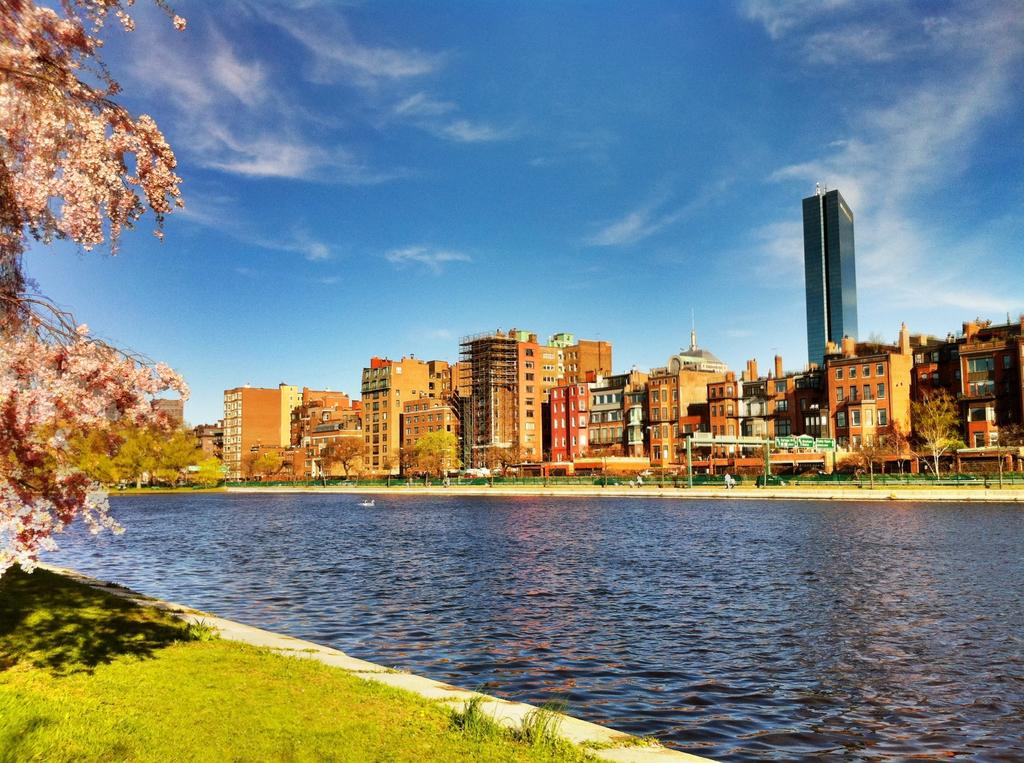What type of structures can be seen in the image? There are buildings in the image. What natural elements are present in the image? There are trees and grass visible in the image. Are there any living beings in the image? Yes, there are people in the image. What other feature can be seen in the image? There is water visible in the image. What is the condition of the sky in the image? The sky has clouds in the image. What type of pie is being served at the event in the image? There is no event or pie present in the image. How many cakes are visible on the table in the image? There are no cakes visible in the image. 